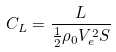<formula> <loc_0><loc_0><loc_500><loc_500>C _ { L } = \frac { L } { \frac { 1 } { 2 } \rho _ { 0 } V _ { e } ^ { 2 } S }</formula> 